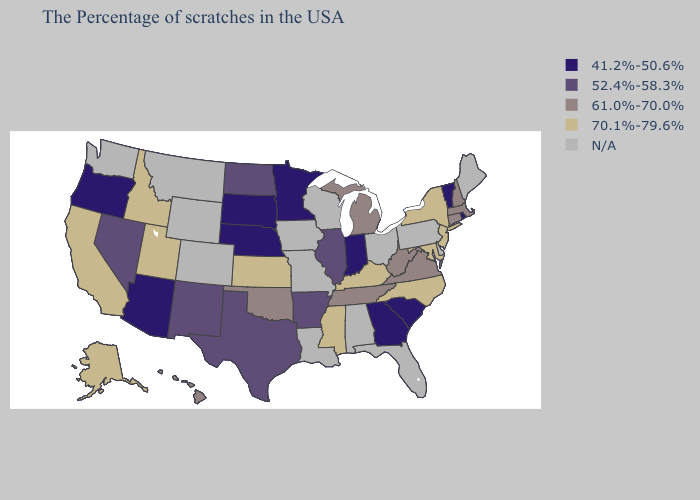What is the value of Kansas?
Give a very brief answer. 70.1%-79.6%. Among the states that border Mississippi , does Arkansas have the highest value?
Give a very brief answer. No. What is the value of Hawaii?
Quick response, please. 61.0%-70.0%. Among the states that border Ohio , which have the highest value?
Be succinct. Kentucky. What is the highest value in the USA?
Quick response, please. 70.1%-79.6%. Does the map have missing data?
Short answer required. Yes. Among the states that border Colorado , which have the highest value?
Write a very short answer. Kansas, Utah. What is the highest value in the West ?
Give a very brief answer. 70.1%-79.6%. Does the map have missing data?
Write a very short answer. Yes. What is the value of South Carolina?
Be succinct. 41.2%-50.6%. What is the highest value in states that border Maryland?
Give a very brief answer. 61.0%-70.0%. Which states have the lowest value in the USA?
Keep it brief. Rhode Island, Vermont, South Carolina, Georgia, Indiana, Minnesota, Nebraska, South Dakota, Arizona, Oregon. Does the map have missing data?
Keep it brief. Yes. Does Maryland have the lowest value in the South?
Concise answer only. No. Does Oklahoma have the lowest value in the USA?
Keep it brief. No. 